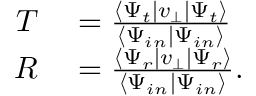<formula> <loc_0><loc_0><loc_500><loc_500>\begin{array} { r l } { T } & = \frac { \langle \Psi _ { t } | v _ { \bot } | \Psi _ { t } \rangle } { \langle \Psi _ { i n } | \Psi _ { i n } \rangle } } \\ { R } & = \frac { \langle \Psi _ { r } | v _ { \bot } | \Psi _ { r } \rangle } { \langle \Psi _ { i n } | \Psi _ { i n } \rangle } . } \end{array}</formula> 